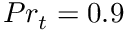Convert formula to latex. <formula><loc_0><loc_0><loc_500><loc_500>P r _ { t } = 0 . 9</formula> 